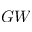<formula> <loc_0><loc_0><loc_500><loc_500>G W</formula> 